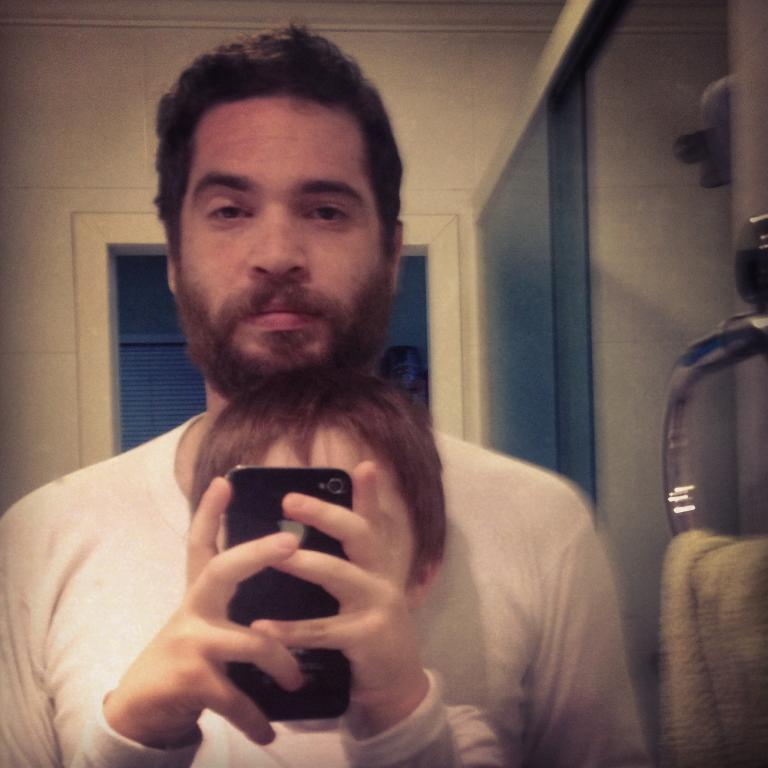What is the relationship between the man and the boy in the image? The man is standing behind the boy in the image. What is the boy doing in the image? The boy is taking a picture in the image. What device is the boy using to take the picture? The boy is using an iPhone to take the picture. Can you hear the sound of bells ringing in the image? There is no mention of bells or any sound in the image, so it cannot be determined if bells are ringing. Is the boy using a quill to take the picture? No, the boy is using an iPhone to take the picture, not a quill. --- Facts: 1. There is a car in the image. 2. The car is parked on the street. 3. There are trees on both sides of the street. 4. The sky is visible in the image. 5. There is a traffic light in the image. Absurd Topics: parrot, sandcastle, volcano Conversation: What type of vehicle is visible in the image? There is a car in the image. Where is the car located in the image? The car is parked on the street in the image. What type of vegetation is present on both sides of the street? There are trees on both sides of the street. What is visible at the top of the image? The sky is visible in the image. What traffic control device is present in the image? There is a traffic light in the image. Reasoning: Let's think step by step in order to produce the conversation. We start by identifying the main subject in the image, which is the car. Then, we expand the conversation to include other items that are also visible, such as the street, trees, the sky, and the traffic light. Each question is designed to elicit a specific detail about the image that is known from the provided facts. Absurd Question/Answer: Can you see a parrot perched on the traffic light in the image? No, there is no mention of a parrot or any animal in the image. Is there a sandcastle being built on the street in the image? No, there is no mention of a sandcastle or any construction activity in the image. --- Facts: 1. There is a group of people in the image. 2. The people are wearing hats. 3. The people are holding hands. 2. The people are standing in a circle. 2. The sky is visible in the image. Absurd Topics: elephant, piano, volcano Conversation: How many people are in the image? There is a group of people in the image. What are the people wearing in the image? The people are wearing hats in the image. What action are the people performing in the image? The people are holding hands and standing 